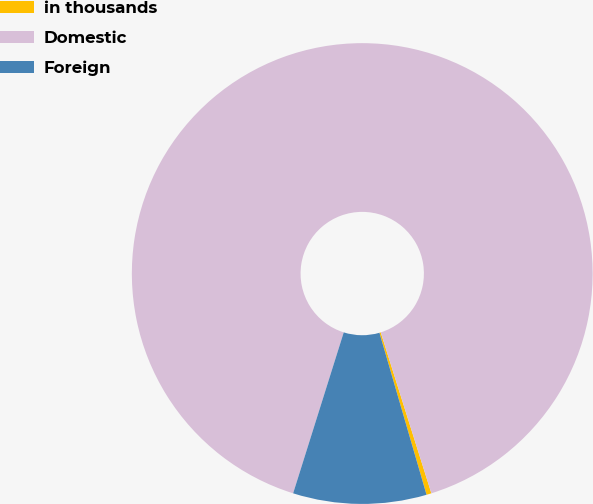Convert chart to OTSL. <chart><loc_0><loc_0><loc_500><loc_500><pie_chart><fcel>in thousands<fcel>Domestic<fcel>Foreign<nl><fcel>0.35%<fcel>90.3%<fcel>9.35%<nl></chart> 